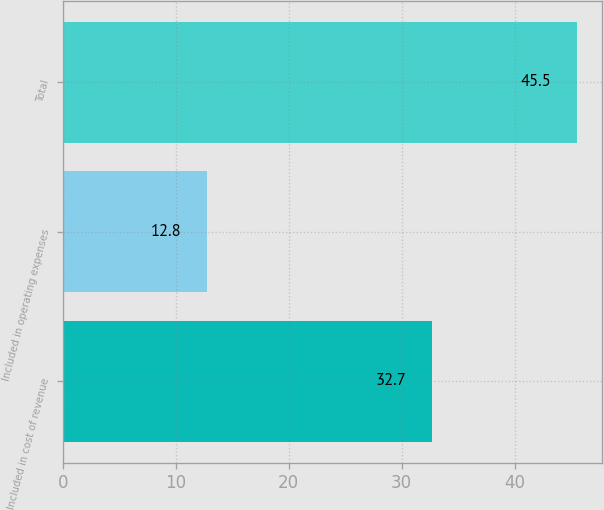<chart> <loc_0><loc_0><loc_500><loc_500><bar_chart><fcel>Included in cost of revenue<fcel>Included in operating expenses<fcel>Total<nl><fcel>32.7<fcel>12.8<fcel>45.5<nl></chart> 